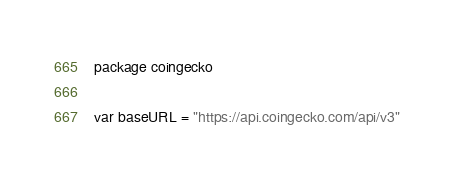Convert code to text. <code><loc_0><loc_0><loc_500><loc_500><_Go_>package coingecko

var baseURL = "https://api.coingecko.com/api/v3"
</code> 